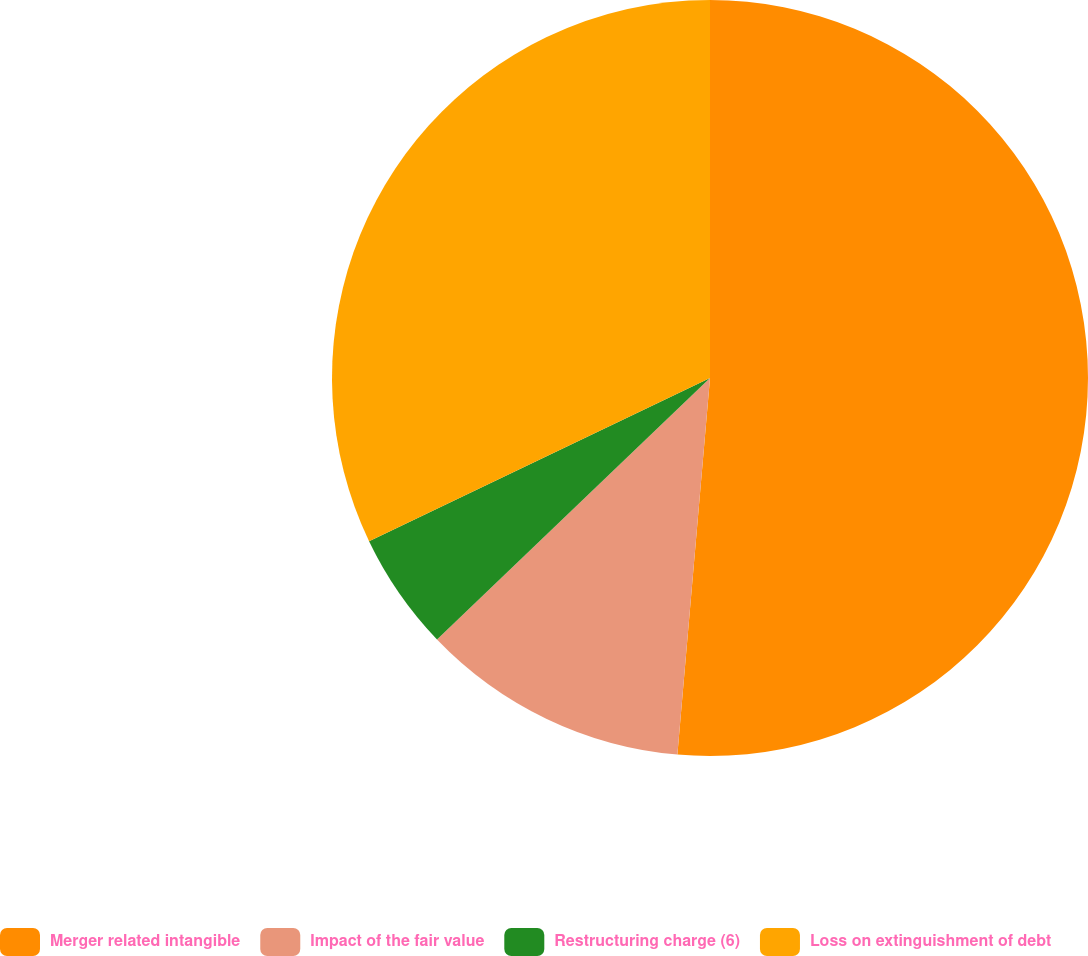Convert chart to OTSL. <chart><loc_0><loc_0><loc_500><loc_500><pie_chart><fcel>Merger related intangible<fcel>Impact of the fair value<fcel>Restructuring charge (6)<fcel>Loss on extinguishment of debt<nl><fcel>51.38%<fcel>11.47%<fcel>5.05%<fcel>32.11%<nl></chart> 